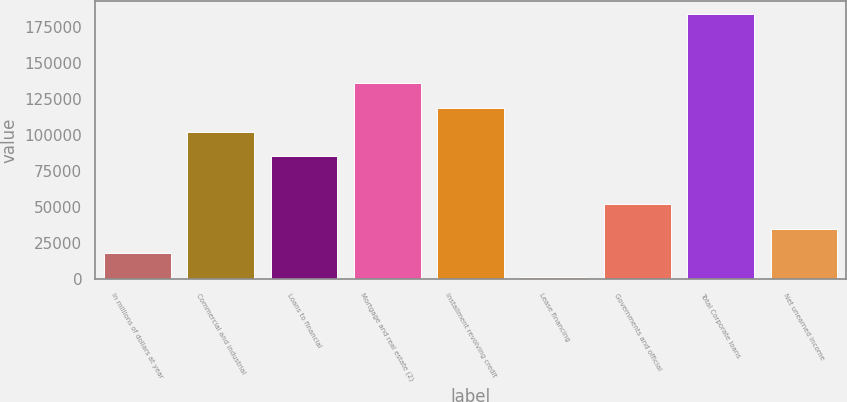Convert chart. <chart><loc_0><loc_0><loc_500><loc_500><bar_chart><fcel>In millions of dollars at year<fcel>Commercial and industrial<fcel>Loans to financial<fcel>Mortgage and real estate (2)<fcel>Installment revolving credit<fcel>Lease financing<fcel>Governments and official<fcel>Total Corporate loans<fcel>Net unearned income<nl><fcel>18139.4<fcel>102351<fcel>85509<fcel>136036<fcel>119194<fcel>1297<fcel>51824.2<fcel>184289<fcel>34981.8<nl></chart> 